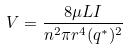<formula> <loc_0><loc_0><loc_500><loc_500>V = \frac { 8 \mu L I } { n ^ { 2 } \pi r ^ { 4 } ( q ^ { * } ) ^ { 2 } }</formula> 